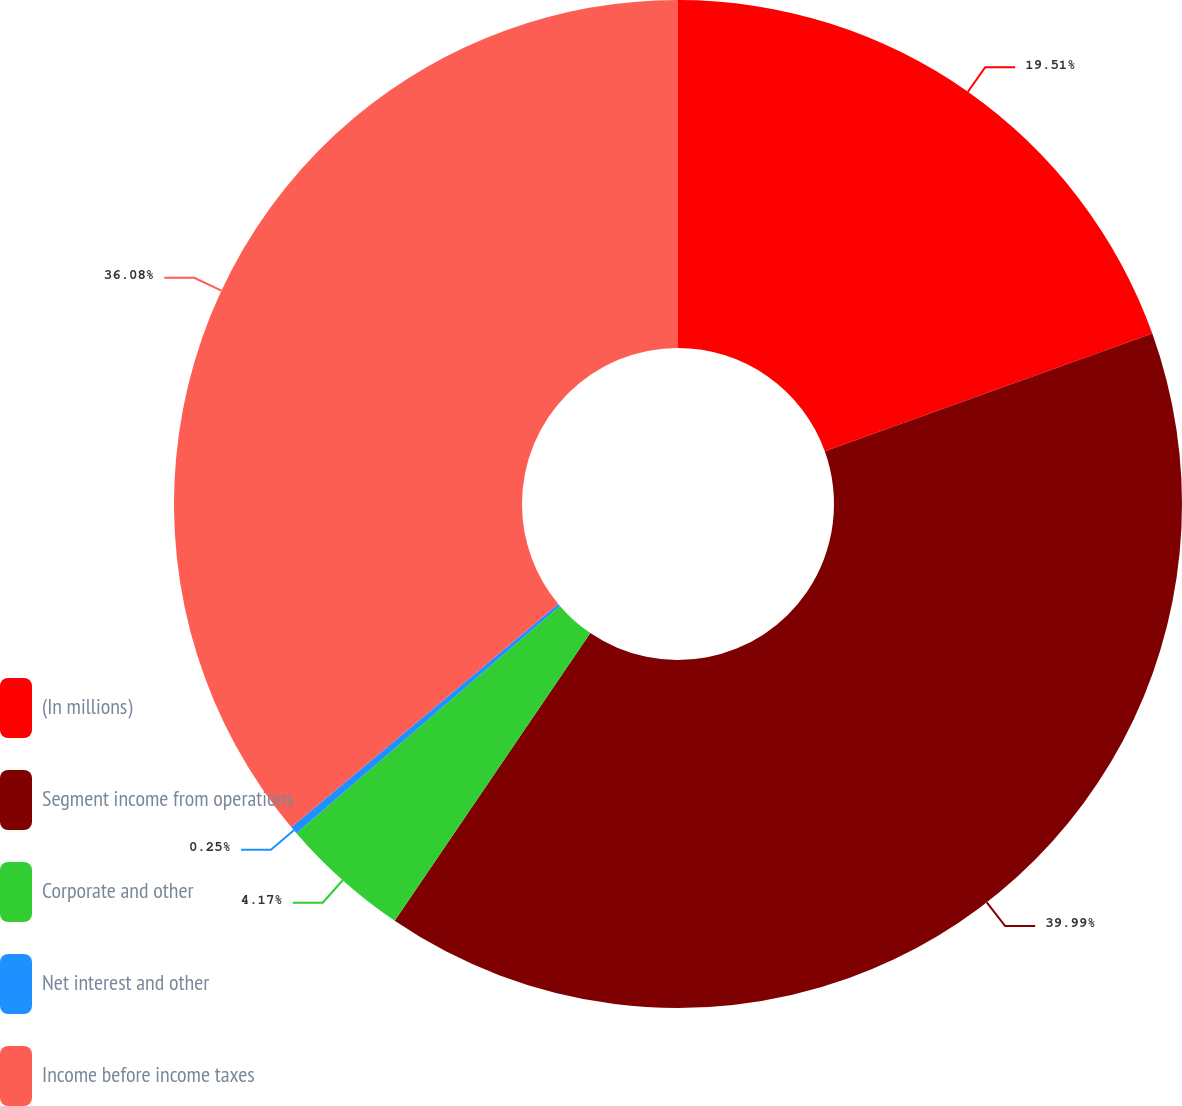<chart> <loc_0><loc_0><loc_500><loc_500><pie_chart><fcel>(In millions)<fcel>Segment income from operations<fcel>Corporate and other<fcel>Net interest and other<fcel>Income before income taxes<nl><fcel>19.51%<fcel>39.99%<fcel>4.17%<fcel>0.25%<fcel>36.08%<nl></chart> 